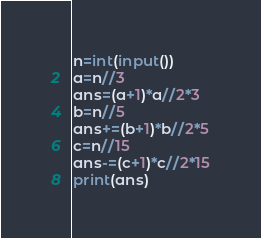<code> <loc_0><loc_0><loc_500><loc_500><_Python_>n=int(input())
a=n//3
ans=(a+1)*a//2*3
b=n//5
ans+=(b+1)*b//2*5
c=n//15
ans-=(c+1)*c//2*15
print(ans)</code> 